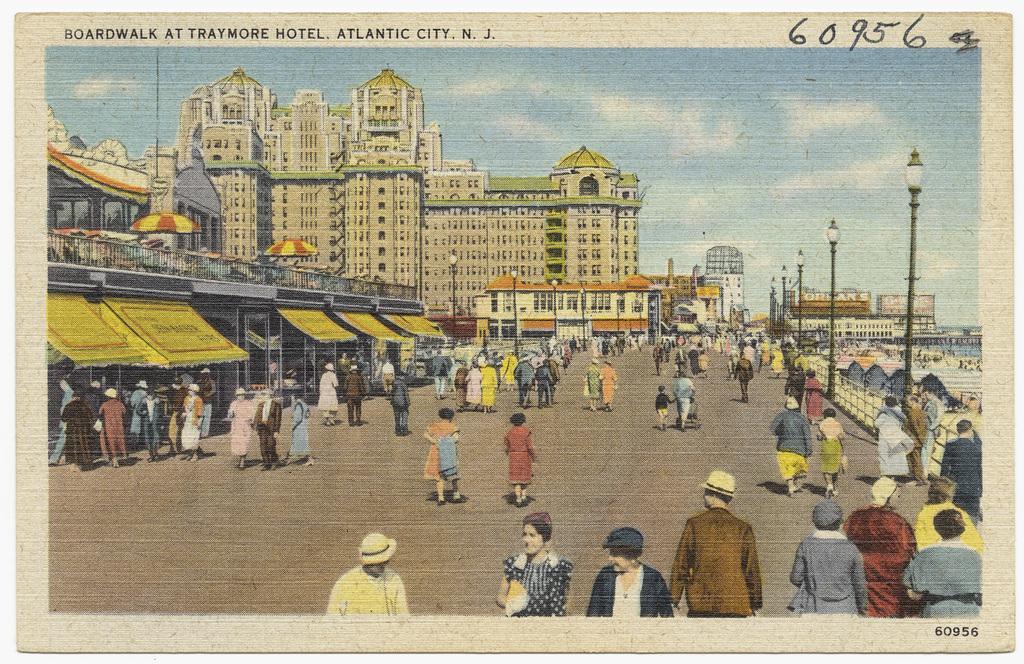Could you give a brief overview of what you see in this image? In this image we can see a photograph. There is a road. There are many people. Some are wearing caps. On the right side there are light poles and railing. On the left side there are buildings. In the background there is sky. At the top something is written on that. 